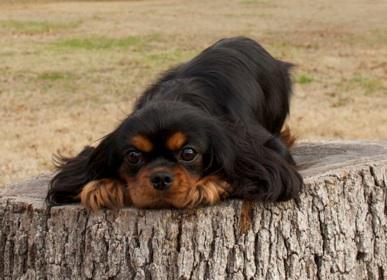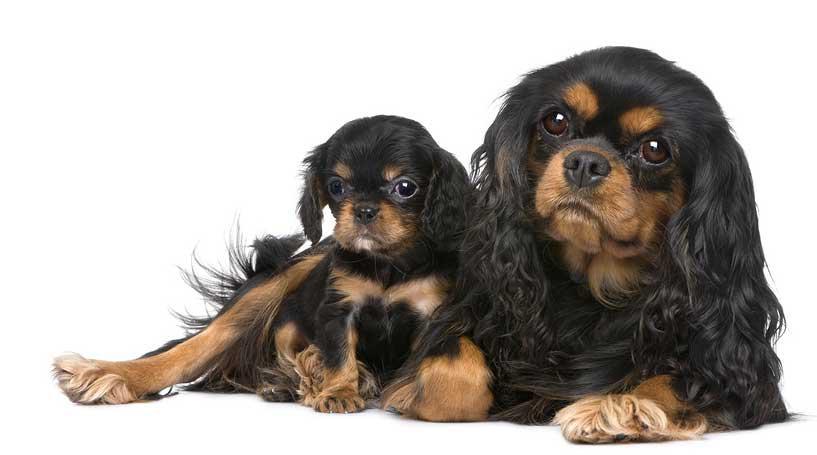The first image is the image on the left, the second image is the image on the right. Analyze the images presented: Is the assertion "One image shows a black and brown spaniel standing and looking up at the camera." valid? Answer yes or no. No. The first image is the image on the left, the second image is the image on the right. For the images shown, is this caption "The dog on the left is sitting on a wood surface." true? Answer yes or no. Yes. The first image is the image on the left, the second image is the image on the right. For the images shown, is this caption "There are three cocker spaniels" true? Answer yes or no. Yes. The first image is the image on the left, the second image is the image on the right. Given the left and right images, does the statement "An image features two similarly colored dogs posed next to each other." hold true? Answer yes or no. Yes. 